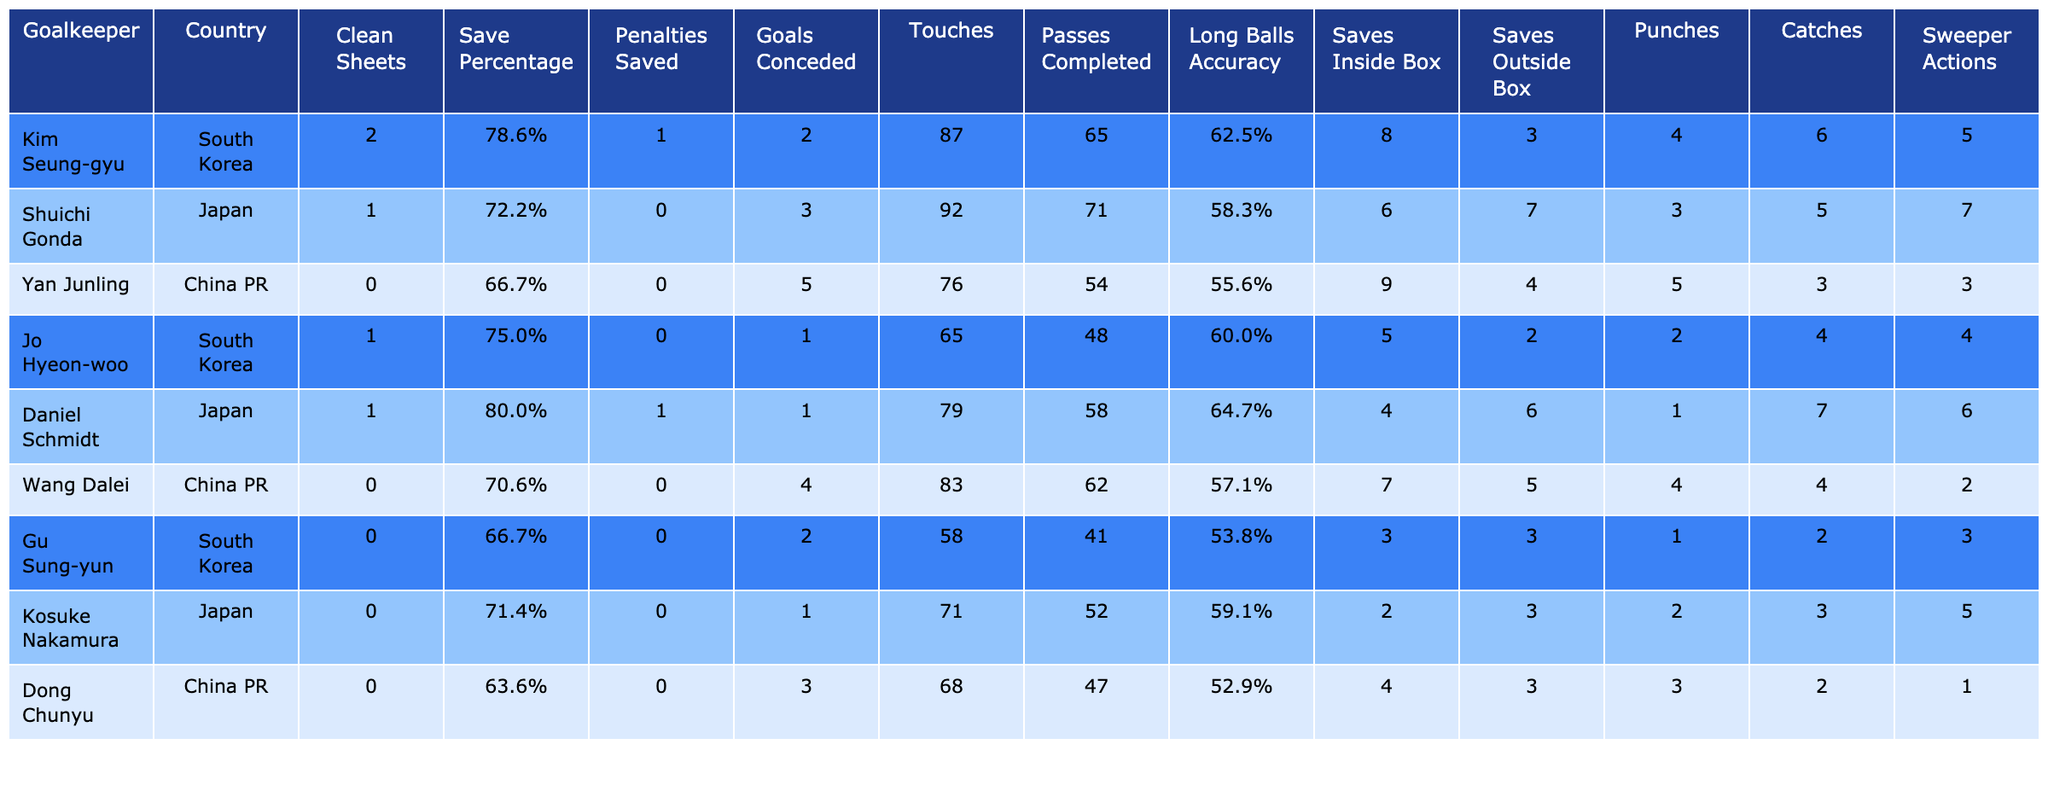What goalkeeper had the highest save percentage? By examining the "Save Percentage" column, we can see that Daniel Schmidt has the highest percentage, at 80.0%.
Answer: Daniel Schmidt How many total clean sheets did the South Korean goalkeepers achieve? The South Korean goalkeepers are Kim Seung-gyu and Jo Hyeon-woo, who had 2 and 1 clean sheets respectively. Therefore, the total clean sheets is 2 + 1 = 3.
Answer: 3 Which goalkeeper conceded the fewest goals? Looking at the "Goals Conceded" column, Jo Hyeon-woo conceded the fewest goals with just 1 goal.
Answer: Jo Hyeon-woo Did any goalkeeper save a penalty? By checking the "Penalties Saved" column, we see that Daniel Schmidt saved 1 penalty, while all others saved none. This confirms the answer is yes.
Answer: Yes What is the average number of saves inside the box made by all goalkeepers? To find this, we sum the "Saves Inside Box" values: (8 + 6 + 9 + 5 + 4 + 7 + 3 + 2 + 4) = 48. Then we divide by the number of goalkeepers, which is 9. Therefore, the average is 48 / 9 ≈ 5.33.
Answer: Approximately 5.33 Which goalkeeper had the highest number of touches? Checking the "Touches" column shows Kim Seung-gyu with 87 touches as the highest among all goalkeepers.
Answer: Kim Seung-gyu What percentage of long balls completed were accurate for Daniel Schmidt? Daniel Schmidt completed 58 long balls with an accuracy of 64.7%, as indicated in the "Long Balls Accuracy" column. This is directly referenced in the table.
Answer: 64.7% How many more saves outside the box did Yan Junling have compared to Gu Sung-yun? Yan Junling made 4 saves outside the box while Gu Sung-yun made 3. Thus, the difference is 4 - 3 = 1 more save for Yan Junling.
Answer: 1 Which country had the best goalkeeper performance in terms of clean sheets? South Korea had the highest total in clean sheets with 3, as Kim Seung-gyu and Jo Hyeon-woo combined for that total, which surpasses the performance from Japan and China PR.
Answer: South Korea What is the total number of goals conceded by all goalkeepers combined? We add the values from the "Goals Conceded" column: (2 + 3 + 5 + 1 + 1 + 4 + 2 + 1 + 3) = 22. So, the total number of goals conceded is 22.
Answer: 22 